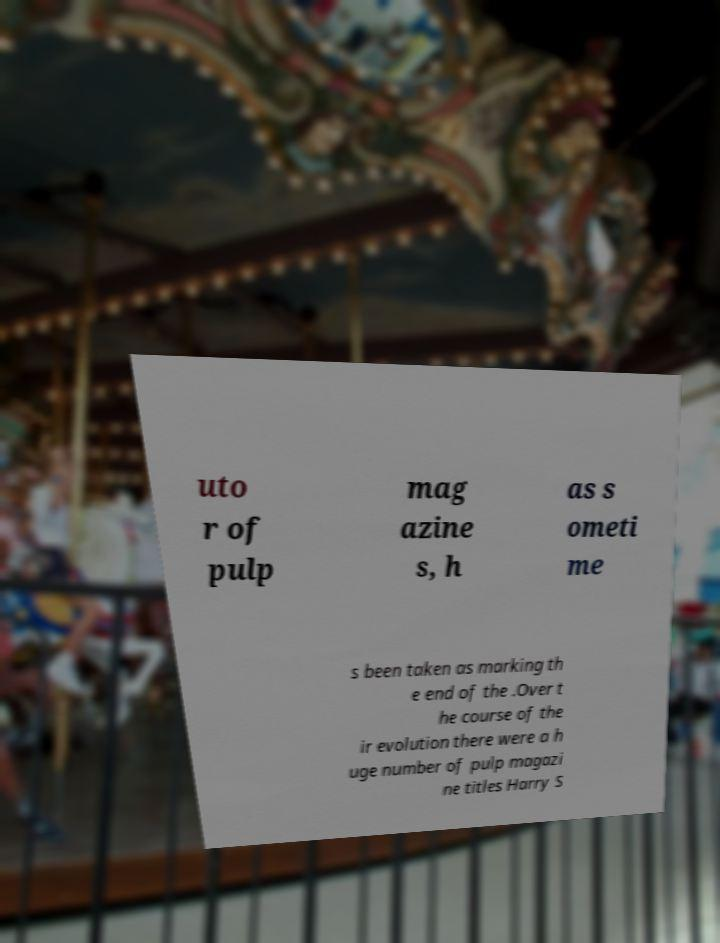What messages or text are displayed in this image? I need them in a readable, typed format. uto r of pulp mag azine s, h as s ometi me s been taken as marking th e end of the .Over t he course of the ir evolution there were a h uge number of pulp magazi ne titles Harry S 